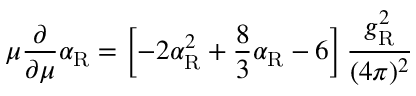Convert formula to latex. <formula><loc_0><loc_0><loc_500><loc_500>\mu \frac { \partial } { \partial \mu } \alpha _ { R } = \left [ - 2 \alpha _ { R } ^ { 2 } + \frac { 8 } { 3 } \alpha _ { R } - 6 \right ] \frac { g _ { R } ^ { 2 } } { ( 4 \pi ) ^ { 2 } }</formula> 